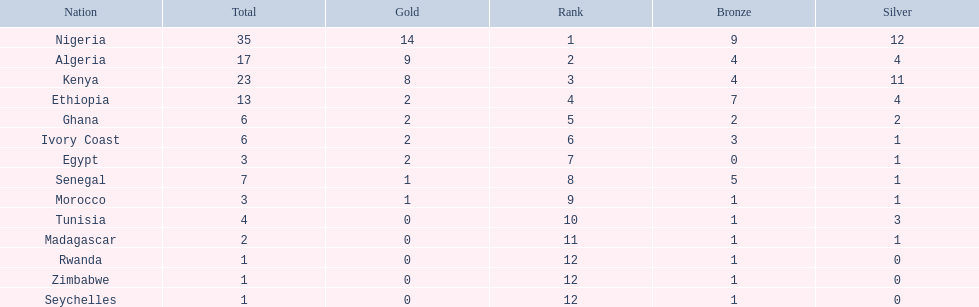What is the name of the first nation on this chart? Nigeria. 